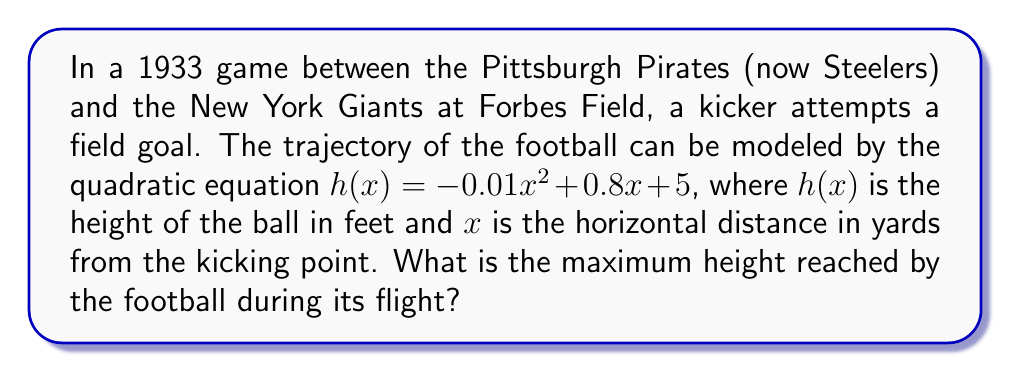Can you answer this question? To find the maximum height of the football, we need to determine the vertex of the parabola described by the quadratic equation. The general form of a quadratic equation is $f(x) = ax^2 + bx + c$, where $a$, $b$, and $c$ are constants and $a \neq 0$.

Given equation: $h(x) = -0.01x^2 + 0.8x + 5$

Step 1: Identify $a$, $b$, and $c$
$a = -0.01$
$b = 0.8$
$c = 5$

Step 2: Use the formula for the x-coordinate of the vertex: $x = -\frac{b}{2a}$

$x = -\frac{0.8}{2(-0.01)} = -\frac{0.8}{-0.02} = 40$ yards

Step 3: Calculate the maximum height by plugging the x-coordinate into the original equation:

$h(40) = -0.01(40)^2 + 0.8(40) + 5$
$= -0.01(1600) + 32 + 5$
$= -16 + 32 + 5$
$= 21$ feet

Therefore, the maximum height reached by the football is 21 feet.
Answer: 21 feet 